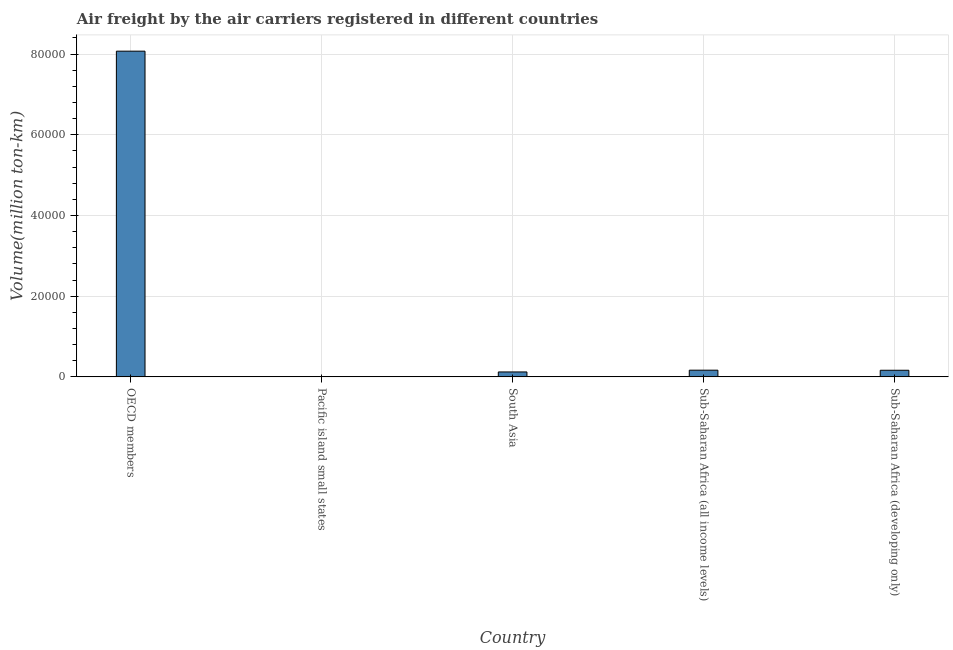Does the graph contain grids?
Offer a very short reply. Yes. What is the title of the graph?
Give a very brief answer. Air freight by the air carriers registered in different countries. What is the label or title of the X-axis?
Provide a succinct answer. Country. What is the label or title of the Y-axis?
Ensure brevity in your answer.  Volume(million ton-km). What is the air freight in OECD members?
Offer a very short reply. 8.07e+04. Across all countries, what is the maximum air freight?
Offer a terse response. 8.07e+04. Across all countries, what is the minimum air freight?
Make the answer very short. 89.1. In which country was the air freight minimum?
Provide a succinct answer. Pacific island small states. What is the sum of the air freight?
Keep it short and to the point. 8.53e+04. What is the difference between the air freight in South Asia and Sub-Saharan Africa (all income levels)?
Your answer should be very brief. -438.7. What is the average air freight per country?
Make the answer very short. 1.71e+04. What is the median air freight?
Your answer should be very brief. 1639.6. In how many countries, is the air freight greater than 24000 million ton-km?
Offer a very short reply. 1. What is the ratio of the air freight in South Asia to that in Sub-Saharan Africa (developing only)?
Provide a short and direct response. 0.74. Is the air freight in South Asia less than that in Sub-Saharan Africa (all income levels)?
Keep it short and to the point. Yes. Is the difference between the air freight in Pacific island small states and Sub-Saharan Africa (developing only) greater than the difference between any two countries?
Your response must be concise. No. What is the difference between the highest and the second highest air freight?
Make the answer very short. 7.91e+04. Is the sum of the air freight in Pacific island small states and Sub-Saharan Africa (developing only) greater than the maximum air freight across all countries?
Offer a very short reply. No. What is the difference between the highest and the lowest air freight?
Make the answer very short. 8.06e+04. In how many countries, is the air freight greater than the average air freight taken over all countries?
Give a very brief answer. 1. Are all the bars in the graph horizontal?
Offer a terse response. No. Are the values on the major ticks of Y-axis written in scientific E-notation?
Keep it short and to the point. No. What is the Volume(million ton-km) in OECD members?
Your response must be concise. 8.07e+04. What is the Volume(million ton-km) of Pacific island small states?
Keep it short and to the point. 89.1. What is the Volume(million ton-km) of South Asia?
Your answer should be compact. 1220.6. What is the Volume(million ton-km) in Sub-Saharan Africa (all income levels)?
Your answer should be very brief. 1659.3. What is the Volume(million ton-km) in Sub-Saharan Africa (developing only)?
Offer a terse response. 1639.6. What is the difference between the Volume(million ton-km) in OECD members and Pacific island small states?
Offer a terse response. 8.06e+04. What is the difference between the Volume(million ton-km) in OECD members and South Asia?
Give a very brief answer. 7.95e+04. What is the difference between the Volume(million ton-km) in OECD members and Sub-Saharan Africa (all income levels)?
Offer a very short reply. 7.91e+04. What is the difference between the Volume(million ton-km) in OECD members and Sub-Saharan Africa (developing only)?
Give a very brief answer. 7.91e+04. What is the difference between the Volume(million ton-km) in Pacific island small states and South Asia?
Provide a succinct answer. -1131.5. What is the difference between the Volume(million ton-km) in Pacific island small states and Sub-Saharan Africa (all income levels)?
Your answer should be very brief. -1570.2. What is the difference between the Volume(million ton-km) in Pacific island small states and Sub-Saharan Africa (developing only)?
Your answer should be very brief. -1550.5. What is the difference between the Volume(million ton-km) in South Asia and Sub-Saharan Africa (all income levels)?
Offer a terse response. -438.7. What is the difference between the Volume(million ton-km) in South Asia and Sub-Saharan Africa (developing only)?
Offer a very short reply. -419. What is the ratio of the Volume(million ton-km) in OECD members to that in Pacific island small states?
Make the answer very short. 905.89. What is the ratio of the Volume(million ton-km) in OECD members to that in South Asia?
Make the answer very short. 66.13. What is the ratio of the Volume(million ton-km) in OECD members to that in Sub-Saharan Africa (all income levels)?
Ensure brevity in your answer.  48.64. What is the ratio of the Volume(million ton-km) in OECD members to that in Sub-Saharan Africa (developing only)?
Offer a very short reply. 49.23. What is the ratio of the Volume(million ton-km) in Pacific island small states to that in South Asia?
Offer a very short reply. 0.07. What is the ratio of the Volume(million ton-km) in Pacific island small states to that in Sub-Saharan Africa (all income levels)?
Your answer should be compact. 0.05. What is the ratio of the Volume(million ton-km) in Pacific island small states to that in Sub-Saharan Africa (developing only)?
Give a very brief answer. 0.05. What is the ratio of the Volume(million ton-km) in South Asia to that in Sub-Saharan Africa (all income levels)?
Your answer should be very brief. 0.74. What is the ratio of the Volume(million ton-km) in South Asia to that in Sub-Saharan Africa (developing only)?
Make the answer very short. 0.74. What is the ratio of the Volume(million ton-km) in Sub-Saharan Africa (all income levels) to that in Sub-Saharan Africa (developing only)?
Offer a very short reply. 1.01. 